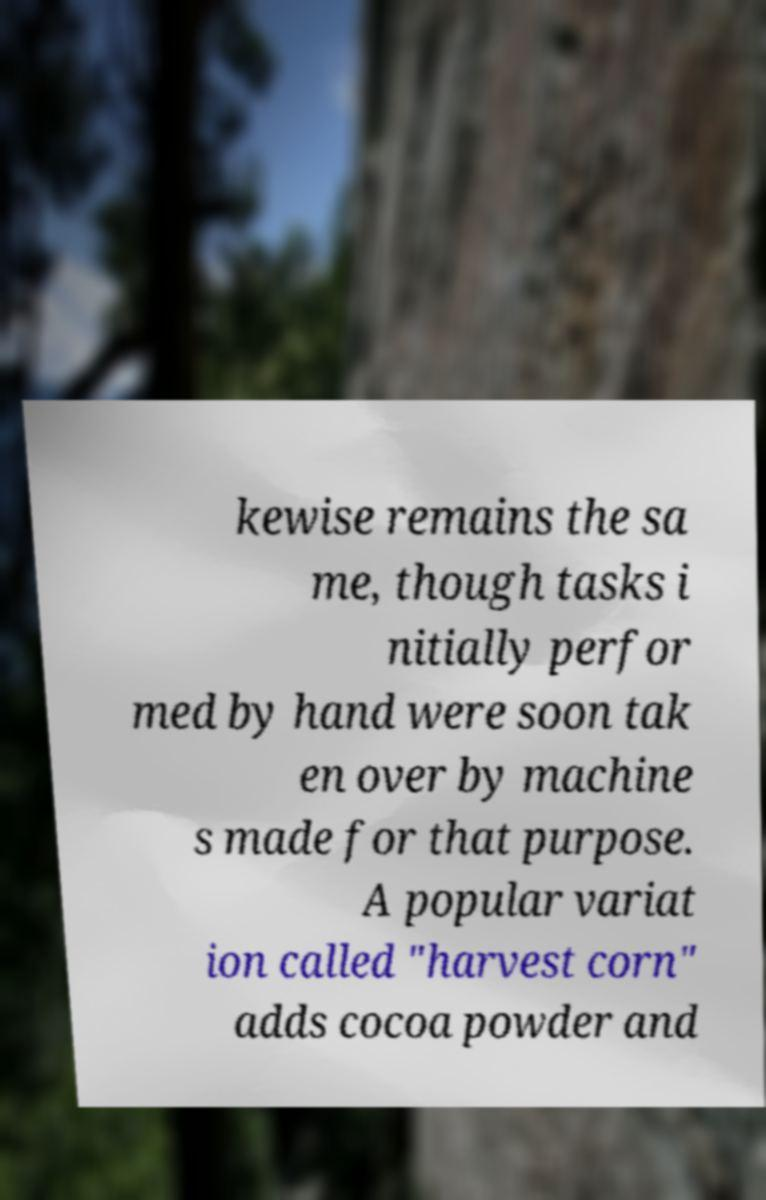Could you assist in decoding the text presented in this image and type it out clearly? kewise remains the sa me, though tasks i nitially perfor med by hand were soon tak en over by machine s made for that purpose. A popular variat ion called "harvest corn" adds cocoa powder and 